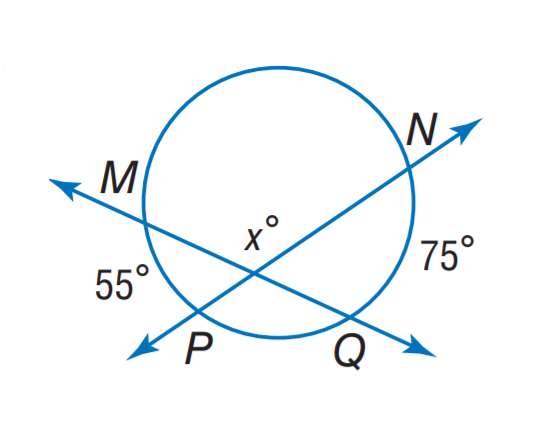Answer the mathemtical geometry problem and directly provide the correct option letter.
Question: Find x.
Choices: A: 95 B: 105 C: 115 D: 125 C 